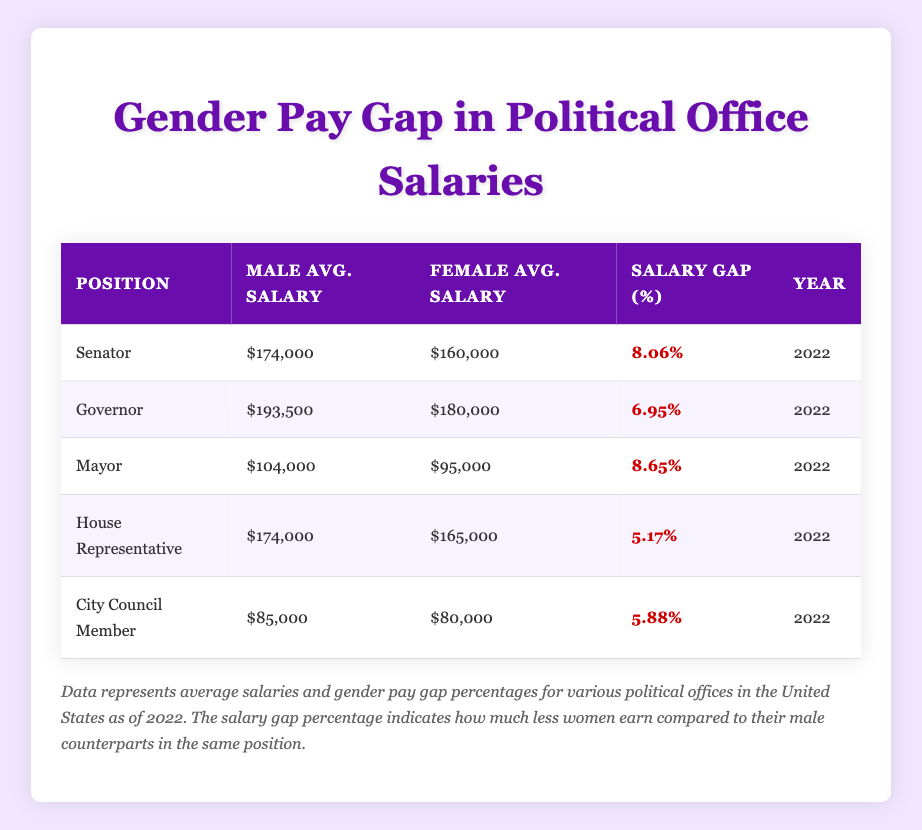What is the average salary for male Senators? The table shows the average salary for male Senators as $174,000.
Answer: $174,000 How much less do female Senators earn compared to their male counterparts? The average salary for female Senators is $160,000. To find the difference, we subtract the female average from the male average: $174,000 - $160,000 = $14,000.
Answer: $14,000 What is the salary gap percentage for Governors? The salary gap percentage for Governors is provided directly in the table as 6.95%.
Answer: 6.95% True or False: The salary gap percentage is higher for Mayors than for House Representatives. The table lists the salary gap percentages: Mayors have 8.65% and House Representatives have 5.17%. Since 8.65% is greater than 5.17%, the statement is True.
Answer: True What is the average salary difference between male and female City Council Members? The average salary for male City Council Members is $85,000, and for females, it is $80,000. To find the difference, subtract: $85,000 - $80,000 = $5,000.
Answer: $5,000 What position has the largest salary gap percentage? By examining the salary gap percentages for all positions in the table, Mayors have the highest percentage at 8.65%.
Answer: Mayors What is the total average salary for both male and female House Representatives? The average salary for male House Representatives is $174,000 and for female House Representatives is $165,000. Summing these figures gives: $174,000 + $165,000 = $339,000.
Answer: $339,000 Which average salary is closer to $100,000, male Governors or female Senators? Male Governors have an average salary of $193,500 and female Senators $160,000. The difference from $100,000 is:
Answer: Female Senators are closer Is the salary gap percentage for female Mayors larger than for female Senators? The salary gap percentage for female Mayors is 8.65%, while for female Senators it is 8.06%. Since 8.65% is greater than 8.06%, the statement is True.
Answer: True 